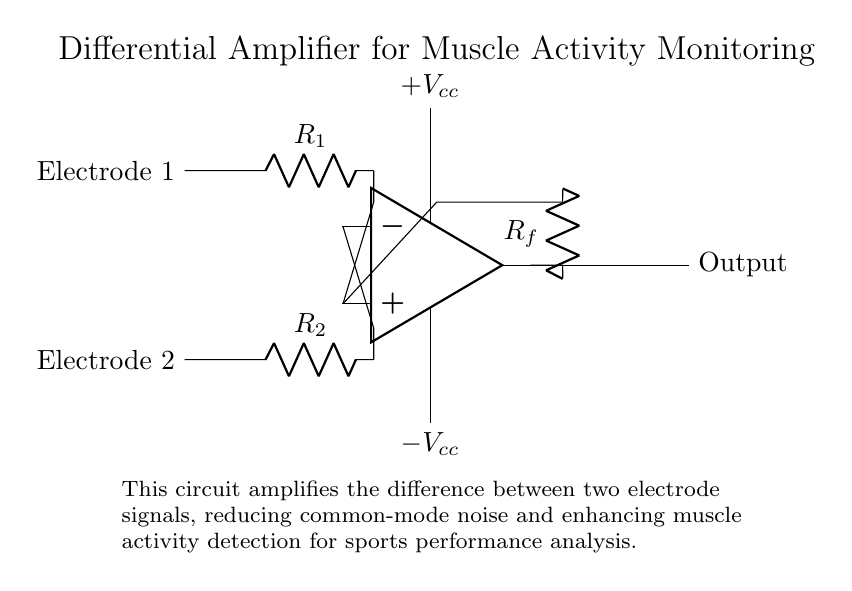What type of amplifier is shown in this circuit? The circuit diagram clearly indicates a differential amplifier, as it is designed to amplify the difference between two input signals. This is supported by the presence of two input electrodes and the operational amplifier configuration.
Answer: differential amplifier What is the role of resistors R1 and R2? Resistors R1 and R2 serve as input resistors for the differential amplifier. They help in establishing the correct gain and ensure that the signals from the two electrodes are appropriately fed into the op-amp.
Answer: input resistors How is the output taken from this circuit? The output is taken from the output terminal of the operational amplifier, which is shown on the right side of the op-amp symbol in the diagram. The circuit connects this output terminal to provide the amplified signal.
Answer: from the output terminal of the op-amp What is the function of resistor Rf? Resistor Rf acts as the feedback resistor in the differential amplifier configuration, allowing a portion of the output signal to be fed back to the inverting input. This feedback controls the gain of the amplifier.
Answer: feedback resistor What does the circuit amplify? The circuit amplifies the difference between the two electrode signals, which is essential for detecting muscle activity while minimizing common noise interference.
Answer: muscle activity difference What voltage levels are provided in this circuit? The circuit is powered by dual supply voltages labeled as plus Vcc and minus Vcc, which are necessary for the operation of the operational amplifier.
Answer: plus Vcc and minus Vcc Why is common-mode noise reduced in this circuit? The differential amplifier inherently rejects common-mode signals due to its design, which amplifies only the difference between its two inputs while ignoring signals that are common to both, thus effectively reducing common-mode noise.
Answer: due to its design 